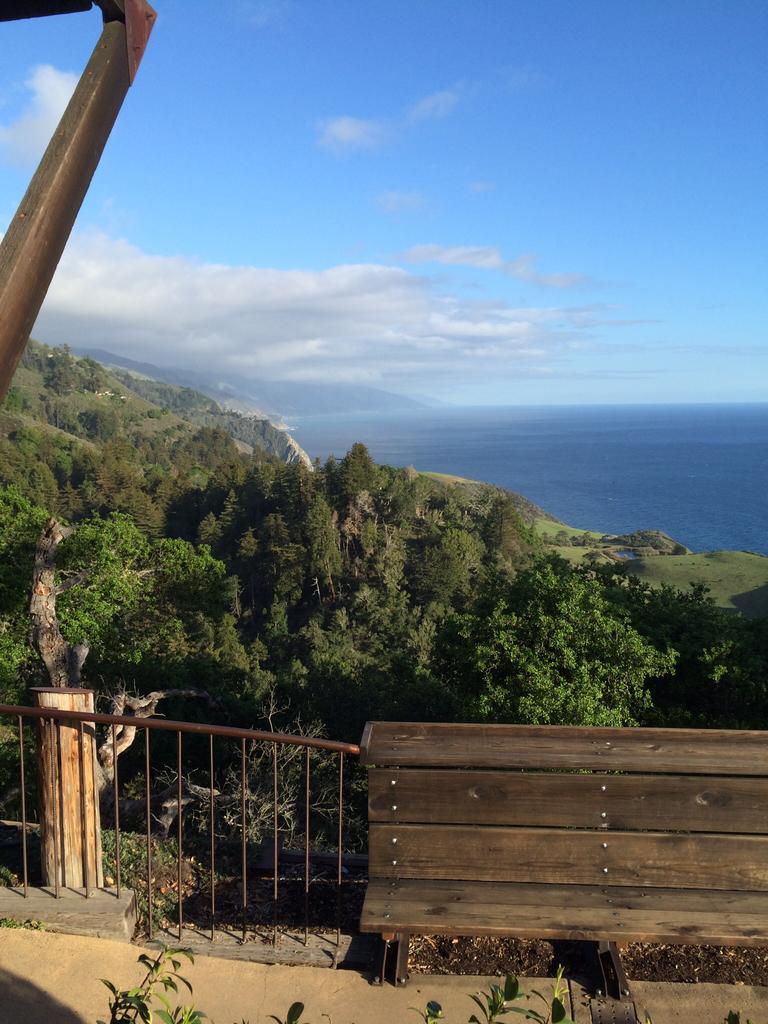In one or two sentences, can you explain what this image depicts? This image consists of trees in the middle. There is a bench at the bottom. There is sky at the top. There is water on the right side. 